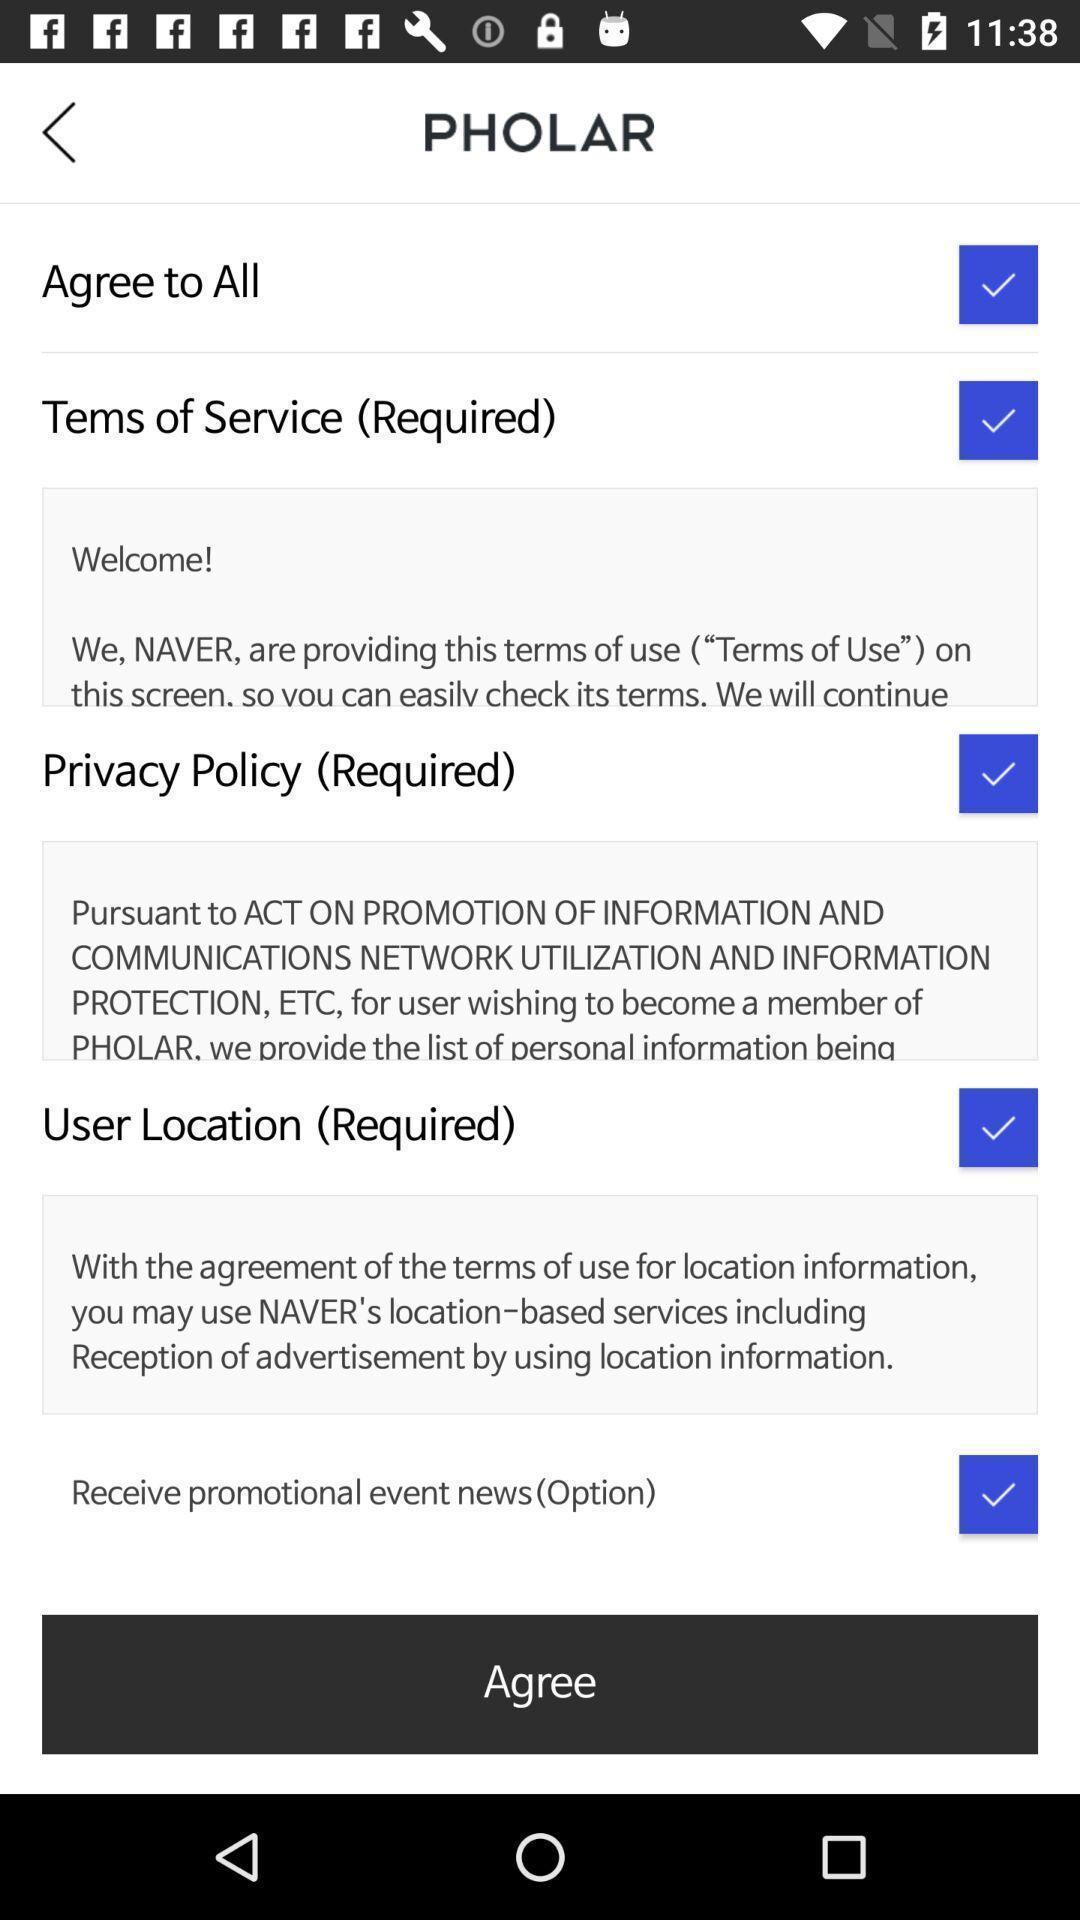Give me a summary of this screen capture. Terms and conditions. 